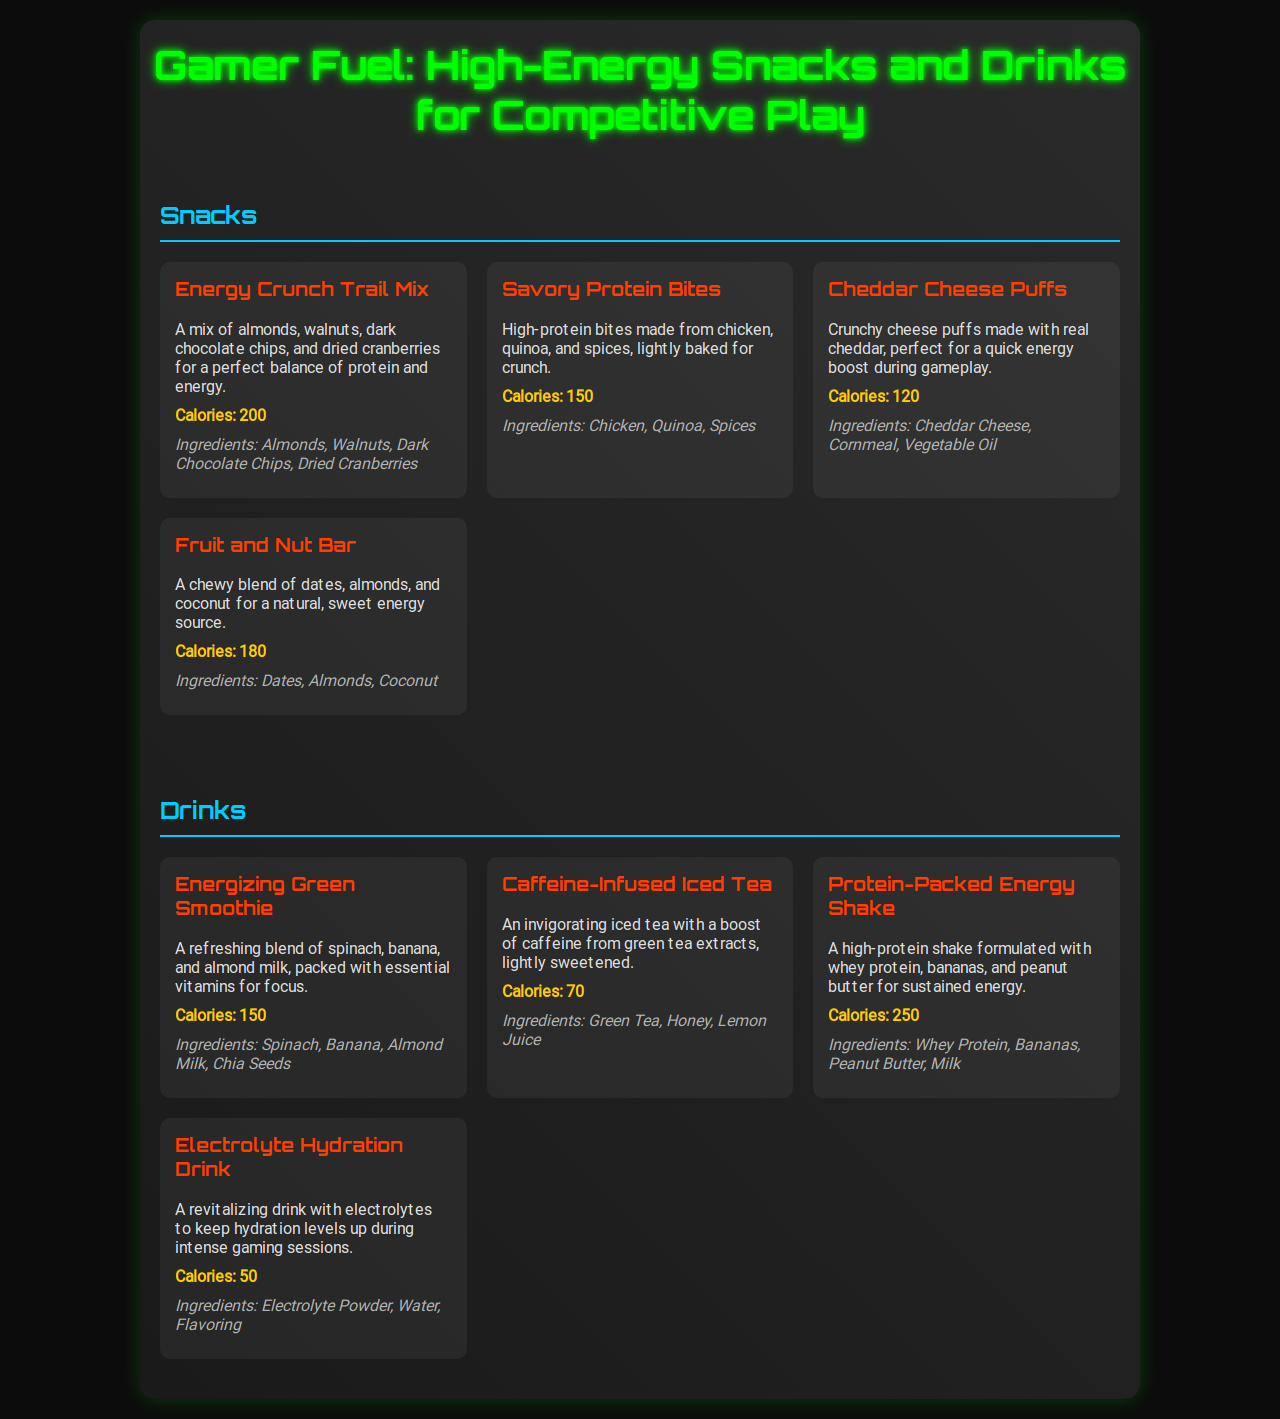what is the first item in the snacks section? The first item in the snacks section is "Energy Crunch Trail Mix."
Answer: Energy Crunch Trail Mix how many calories are in the Protein-Packed Energy Shake? The Protein-Packed Energy Shake has 250 calories listed in the document.
Answer: 250 what ingredients are in the Savory Protein Bites? The ingredients for the Savory Protein Bites are stated as Chicken, Quinoa, and Spices.
Answer: Chicken, Quinoa, Spices which drink has the lowest calorie count? The drink with the lowest calorie count is the Electrolyte Hydration Drink, which has 50 calories.
Answer: 50 how many snacks are listed on the menu? There are four snacks listed on the menu in the snacks section.
Answer: 4 what is the main fruit used in the Energizing Green Smoothie? The main fruit used in the Energizing Green Smoothie is Banana.
Answer: Banana which snack contains dark chocolate? The snack that contains dark chocolate is the Energy Crunch Trail Mix.
Answer: Energy Crunch Trail Mix what type of tea is used in the Caffeine-Infused Iced Tea? The type of tea used is Green Tea.
Answer: Green Tea what is the title of the menu? The title of the menu is "Gamer Fuel: High-Energy Snacks and Drinks for Competitive Play."
Answer: Gamer Fuel: High-Energy Snacks and Drinks for Competitive Play 